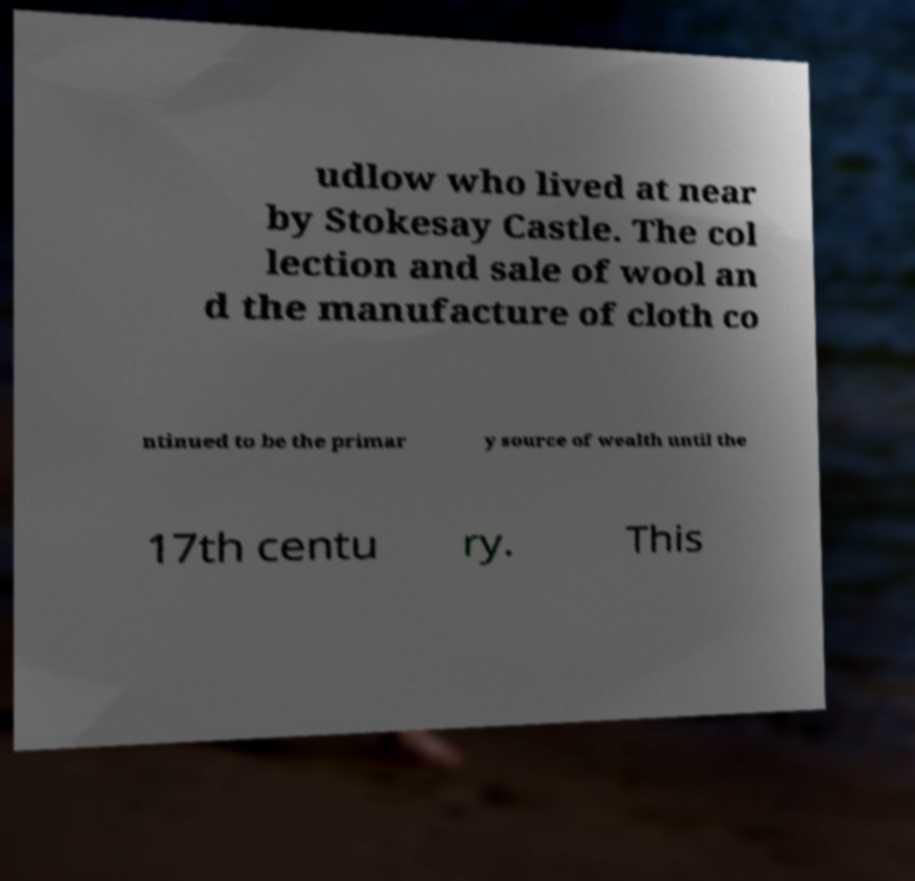Please identify and transcribe the text found in this image. udlow who lived at near by Stokesay Castle. The col lection and sale of wool an d the manufacture of cloth co ntinued to be the primar y source of wealth until the 17th centu ry. This 